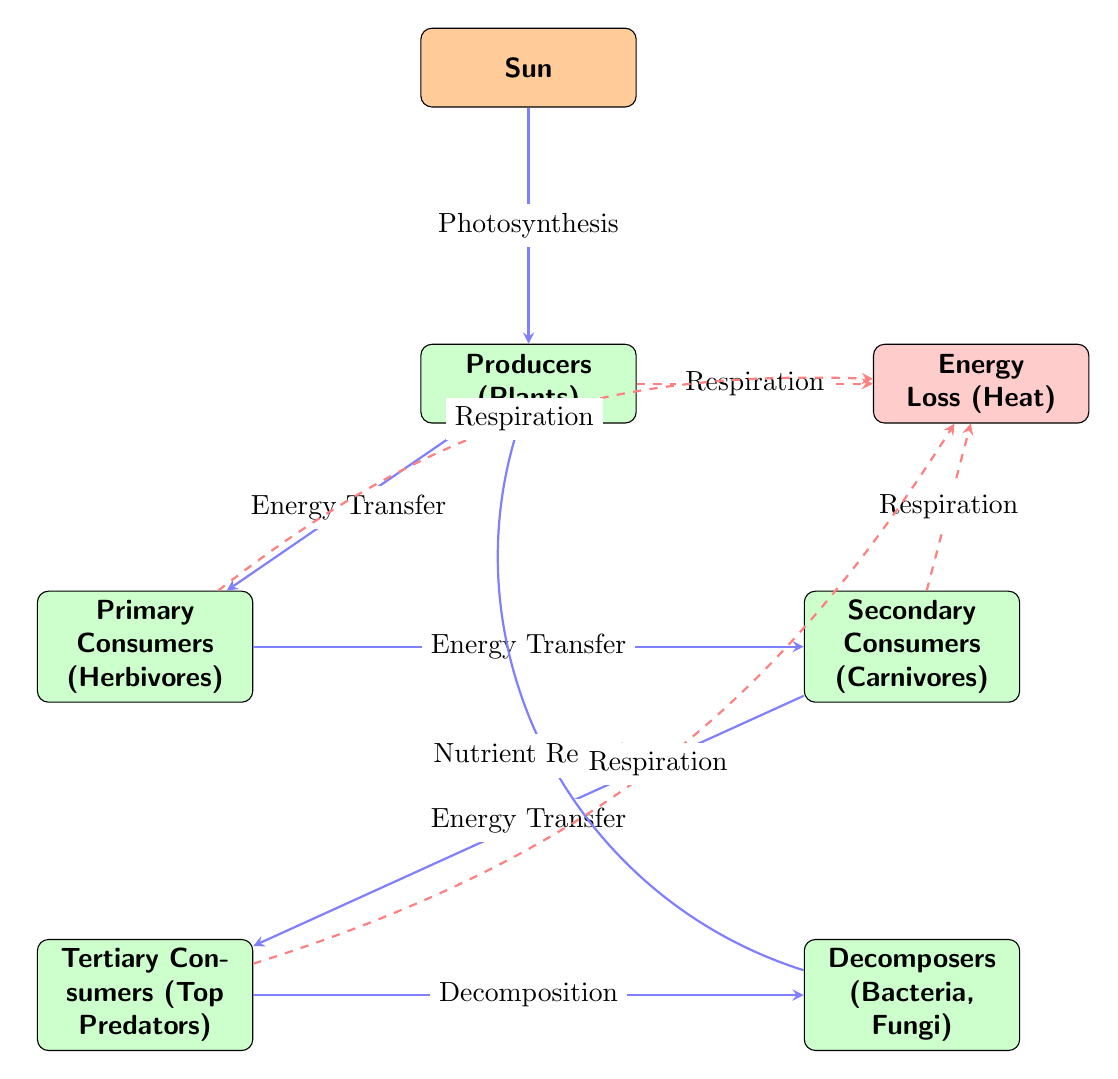What is the primary source of energy in this ecosystem? The diagram clearly shows that the sun is positioned at the top and is labeled as the energy source. This indicates that all energy in the ecosystem flows from the sun, making it the primary source.
Answer: Sun How many trophic levels are represented in the diagram? By counting the nodes beneath the sun, we identify five distinct trophic levels: producers, primary consumers, secondary consumers, tertiary consumers, and decomposers. This totals to five trophic levels.
Answer: 5 What process do producers use to convert solar energy into chemical energy? The interaction arrow from the sun to the producers is labeled "Photosynthesis," indicating this is the process that producers utilize to convert solar energy into chemical energy.
Answer: Photosynthesis Which type of consumer is directly above the decomposers in the energy flow? Looking at the hierarchy in the diagram, the decomposer node points to the tertiary consumer node, indicating that the tertiary consumers are directly above decomposers.
Answer: Tertiary Consumers What happens to energy during respiration according to the diagram? The energy flow arrows from the producers, primary consumers, secondary consumers, and tertiary consumers all point towards an "Energy Loss (Heat)" node, indicating that energy is lost as heat during respiration.
Answer: Heat How are nutrients recycled back to the producers? The arrow labeled "Nutrient Recycling" is shown bending from the decomposer back to the producers, illustrating the process through which nutrients are returned to the producers after decomposition.
Answer: Nutrient Recycling What is the role of the secondary consumers in the energy transfer process? The diagram indicates that secondary consumers receive energy from primary consumers, as denoted by the labeled interaction arrow "Energy Transfer." They play the role of transferring energy to the next level in the food chain.
Answer: Energy Transfer Which trophic level is responsible for breaking down organic matter? The diagram clearly identifies the decomposers, which are at the bottom of the flow and labeled explicitly as breaking down organic matter, showcasing their vital role in the energy cycle.
Answer: Decomposers 